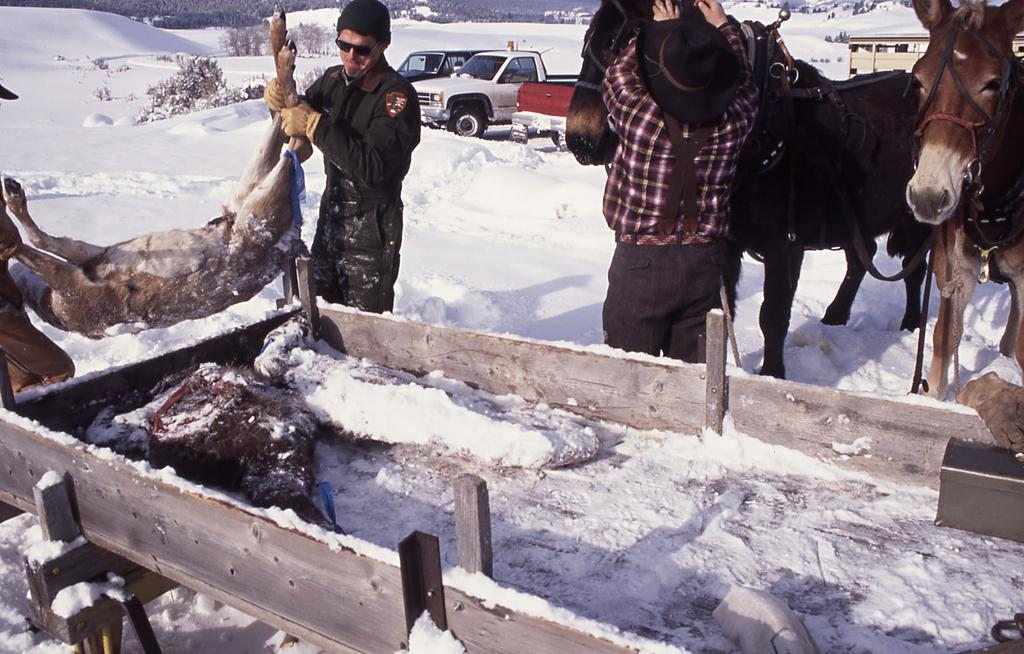What is the main subject of the image? There is a person in the image. What is the person doing in the image? The person is standing and holding a horse. What can be seen in the background of the image? There is snow and vehicles in the background of the image. What type of furniture is visible in the image? There is no furniture present in the image. How many chickens can be seen in the image? There are no chickens present in the image. 